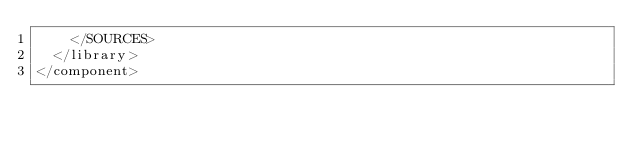Convert code to text. <code><loc_0><loc_0><loc_500><loc_500><_XML_>    </SOURCES>
  </library>
</component></code> 